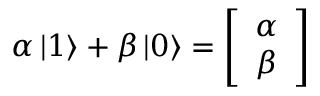<formula> <loc_0><loc_0><loc_500><loc_500>\alpha \left | 1 \right \rangle + \beta \left | 0 \right \rangle = { \left [ \begin{array} { l } { \alpha } \\ { \beta } \end{array} \right ] }</formula> 